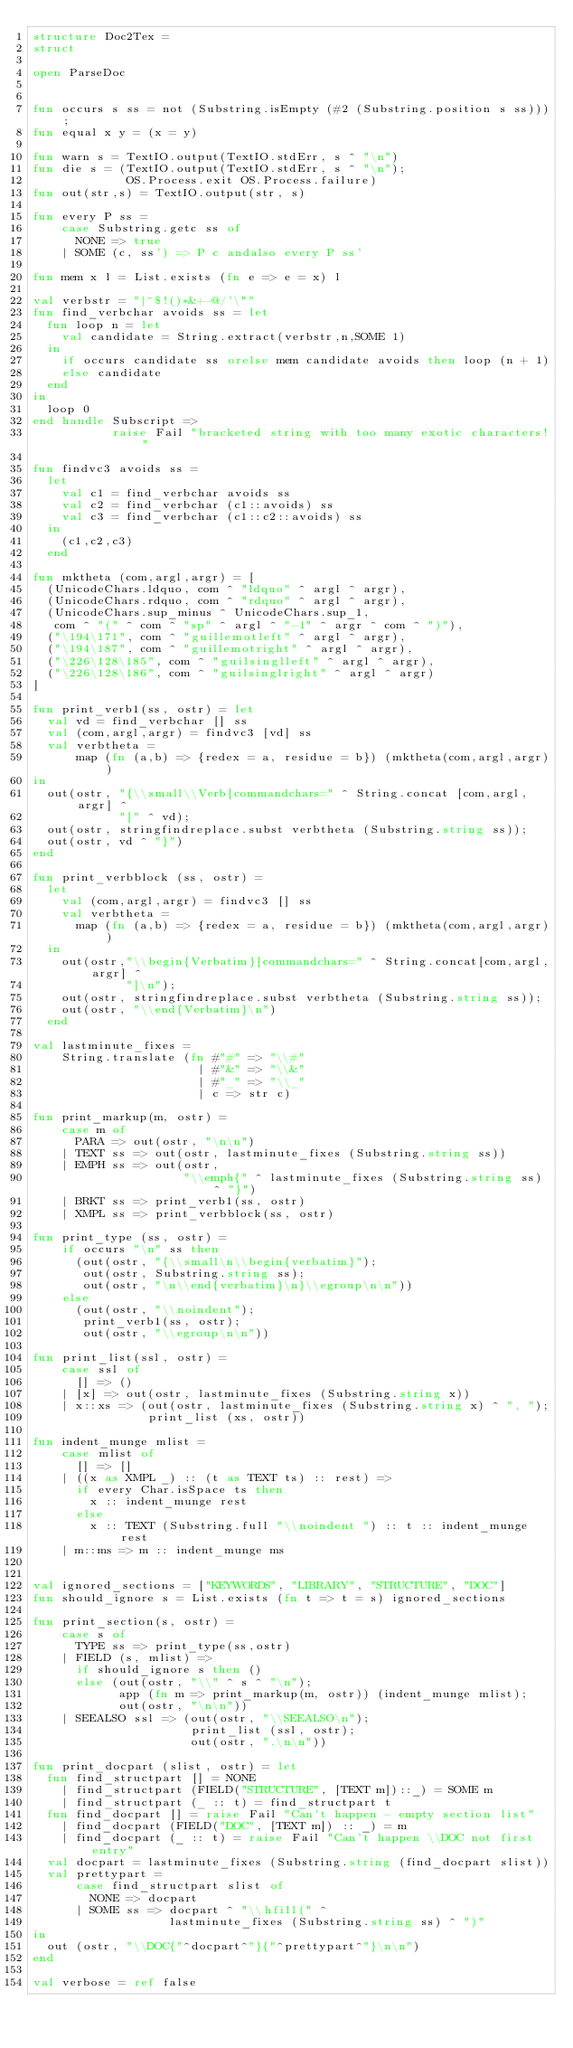<code> <loc_0><loc_0><loc_500><loc_500><_SML_>structure Doc2Tex =
struct

open ParseDoc


fun occurs s ss = not (Substring.isEmpty (#2 (Substring.position s ss)));
fun equal x y = (x = y)

fun warn s = TextIO.output(TextIO.stdErr, s ^ "\n")
fun die s = (TextIO.output(TextIO.stdErr, s ^ "\n");
             OS.Process.exit OS.Process.failure)
fun out(str,s) = TextIO.output(str, s)

fun every P ss =
    case Substring.getc ss of
      NONE => true
    | SOME (c, ss') => P c andalso every P ss'

fun mem x l = List.exists (fn e => e = x) l

val verbstr = "|^$!()*&+-@/'\""
fun find_verbchar avoids ss = let
  fun loop n = let
    val candidate = String.extract(verbstr,n,SOME 1)
  in
    if occurs candidate ss orelse mem candidate avoids then loop (n + 1)
    else candidate
  end
in
  loop 0
end handle Subscript =>
           raise Fail "bracketed string with too many exotic characters!"

fun findvc3 avoids ss =
  let
    val c1 = find_verbchar avoids ss
    val c2 = find_verbchar (c1::avoids) ss
    val c3 = find_verbchar (c1::c2::avoids) ss
  in
    (c1,c2,c3)
  end

fun mktheta (com,argl,argr) = [
  (UnicodeChars.ldquo, com ^ "ldquo" ^ argl ^ argr),
  (UnicodeChars.rdquo, com ^ "rdquo" ^ argl ^ argr),
  (UnicodeChars.sup_minus ^ UnicodeChars.sup_1,
   com ^ "(" ^ com ^ "sp" ^ argl ^ "-1" ^ argr ^ com ^ ")"),
  ("\194\171", com ^ "guillemotleft" ^ argl ^ argr),
  ("\194\187", com ^ "guillemotright" ^ argl ^ argr),
  ("\226\128\185", com ^ "guilsinglleft" ^ argl ^ argr),
  ("\226\128\186", com ^ "guilsinglright" ^ argl ^ argr)
]

fun print_verb1(ss, ostr) = let
  val vd = find_verbchar [] ss
  val (com,argl,argr) = findvc3 [vd] ss
  val verbtheta =
      map (fn (a,b) => {redex = a, residue = b}) (mktheta(com,argl,argr))
in
  out(ostr, "{\\small\\Verb[commandchars=" ^ String.concat [com,argl,argr] ^
            "]" ^ vd);
  out(ostr, stringfindreplace.subst verbtheta (Substring.string ss));
  out(ostr, vd ^ "}")
end

fun print_verbblock (ss, ostr) =
  let
    val (com,argl,argr) = findvc3 [] ss
    val verbtheta =
      map (fn (a,b) => {redex = a, residue = b}) (mktheta(com,argl,argr))
  in
    out(ostr,"\\begin{Verbatim}[commandchars=" ^ String.concat[com,argl,argr] ^
             "]\n");
    out(ostr, stringfindreplace.subst verbtheta (Substring.string ss));
    out(ostr, "\\end{Verbatim}\n")
  end

val lastminute_fixes =
    String.translate (fn #"#" => "\\#"
                       | #"&" => "\\&"
                       | #"_" => "\\_"
                       | c => str c)

fun print_markup(m, ostr) =
    case m of
      PARA => out(ostr, "\n\n")
    | TEXT ss => out(ostr, lastminute_fixes (Substring.string ss))
    | EMPH ss => out(ostr,
                     "\\emph{" ^ lastminute_fixes (Substring.string ss) ^ "}")
    | BRKT ss => print_verb1(ss, ostr)
    | XMPL ss => print_verbblock(ss, ostr)

fun print_type (ss, ostr) =
    if occurs "\n" ss then
      (out(ostr, "{\\small\n\\begin{verbatim}");
       out(ostr, Substring.string ss);
       out(ostr, "\n\\end{verbatim}\n}\\egroup\n\n"))
    else
      (out(ostr, "\\noindent");
       print_verb1(ss, ostr);
       out(ostr, "\\egroup\n\n"))

fun print_list(ssl, ostr) =
    case ssl of
      [] => ()
    | [x] => out(ostr, lastminute_fixes (Substring.string x))
    | x::xs => (out(ostr, lastminute_fixes (Substring.string x) ^ ", ");
                print_list (xs, ostr))

fun indent_munge mlist =
    case mlist of
      [] => []
    | ((x as XMPL _) :: (t as TEXT ts) :: rest) =>
      if every Char.isSpace ts then
        x :: indent_munge rest
      else
        x :: TEXT (Substring.full "\\noindent ") :: t :: indent_munge rest
    | m::ms => m :: indent_munge ms


val ignored_sections = ["KEYWORDS", "LIBRARY", "STRUCTURE", "DOC"]
fun should_ignore s = List.exists (fn t => t = s) ignored_sections

fun print_section(s, ostr) =
    case s of
      TYPE ss => print_type(ss,ostr)
    | FIELD (s, mlist) =>
      if should_ignore s then ()
      else (out(ostr, "\\" ^ s ^ "\n");
            app (fn m => print_markup(m, ostr)) (indent_munge mlist);
            out(ostr, "\n\n"))
    | SEEALSO ssl => (out(ostr, "\\SEEALSO\n");
                      print_list (ssl, ostr);
                      out(ostr, ".\n\n"))

fun print_docpart (slist, ostr) = let
  fun find_structpart [] = NONE
    | find_structpart (FIELD("STRUCTURE", [TEXT m])::_) = SOME m
    | find_structpart (_ :: t) = find_structpart t
  fun find_docpart [] = raise Fail "Can't happen - empty section list"
    | find_docpart (FIELD("DOC", [TEXT m]) :: _) = m
    | find_docpart (_ :: t) = raise Fail "Can't happen \\DOC not first entry"
  val docpart = lastminute_fixes (Substring.string (find_docpart slist))
  val prettypart =
      case find_structpart slist of
        NONE => docpart
      | SOME ss => docpart ^ "\\hfill(" ^
                   lastminute_fixes (Substring.string ss) ^ ")"
in
  out (ostr, "\\DOC{"^docpart^"}{"^prettypart^"}\n\n")
end

val verbose = ref false
</code> 